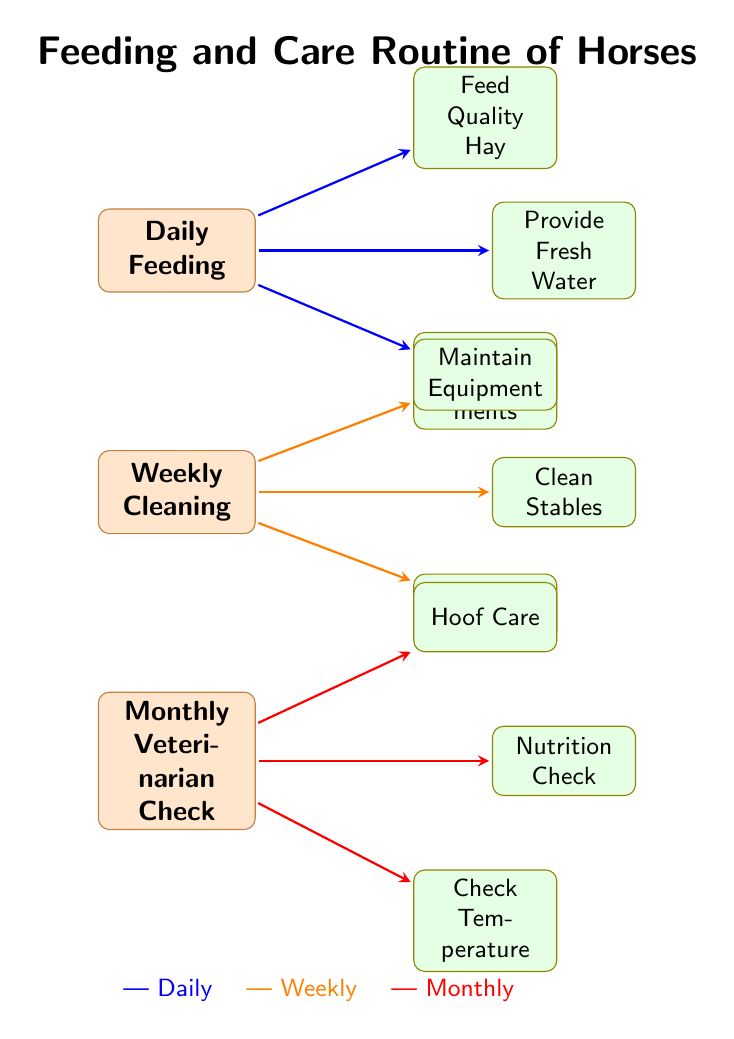What are the three main categories of care outlined in the diagram? The diagram lists three main categories of care: Daily Feeding, Weekly Cleaning, and Monthly Veterinarian Check.
Answer: Daily Feeding, Weekly Cleaning, Monthly Veterinarian Check What color represents daily activities in the diagram? The arrows indicating daily activities are colored blue.
Answer: Blue How many daily activities are shown in the diagram? There are three daily activities associated with Daily Feeding: Provide Fresh Water, Feed Quality Hay, and Administer Supplements.
Answer: Three What is one of the activities included in the weekly cleaning routine? One of the activities in the weekly routine is Clean Stables, as indicated by the connection from Weekly Cleaning.
Answer: Clean Stables If you administer supplements, under which category does this activity fall? The Administer Supplements activity falls under Daily Feeding, as shown in the diagram where it is connected to the Daily Feeding node.
Answer: Daily Feeding Which activity is represented by the green node related to weekly care? The green node related to weekly care represents Grooming, as shown in the diagram.
Answer: Grooming What is the last activity indicated under monthly care? The last activity under monthly care is Check Temperature, based on its position in the diagram.
Answer: Check Temperature How many connections are there from the monthly care node? There are three connections originating from the Monthly Veterinarian Check node, leading to Nutrition Check, Hoof Care, and Check Temperature.
Answer: Three What type of maintenance is included in the weekly activities? The diagram mentions Maintain Equipment as part of the weekly activities.
Answer: Maintain Equipment 